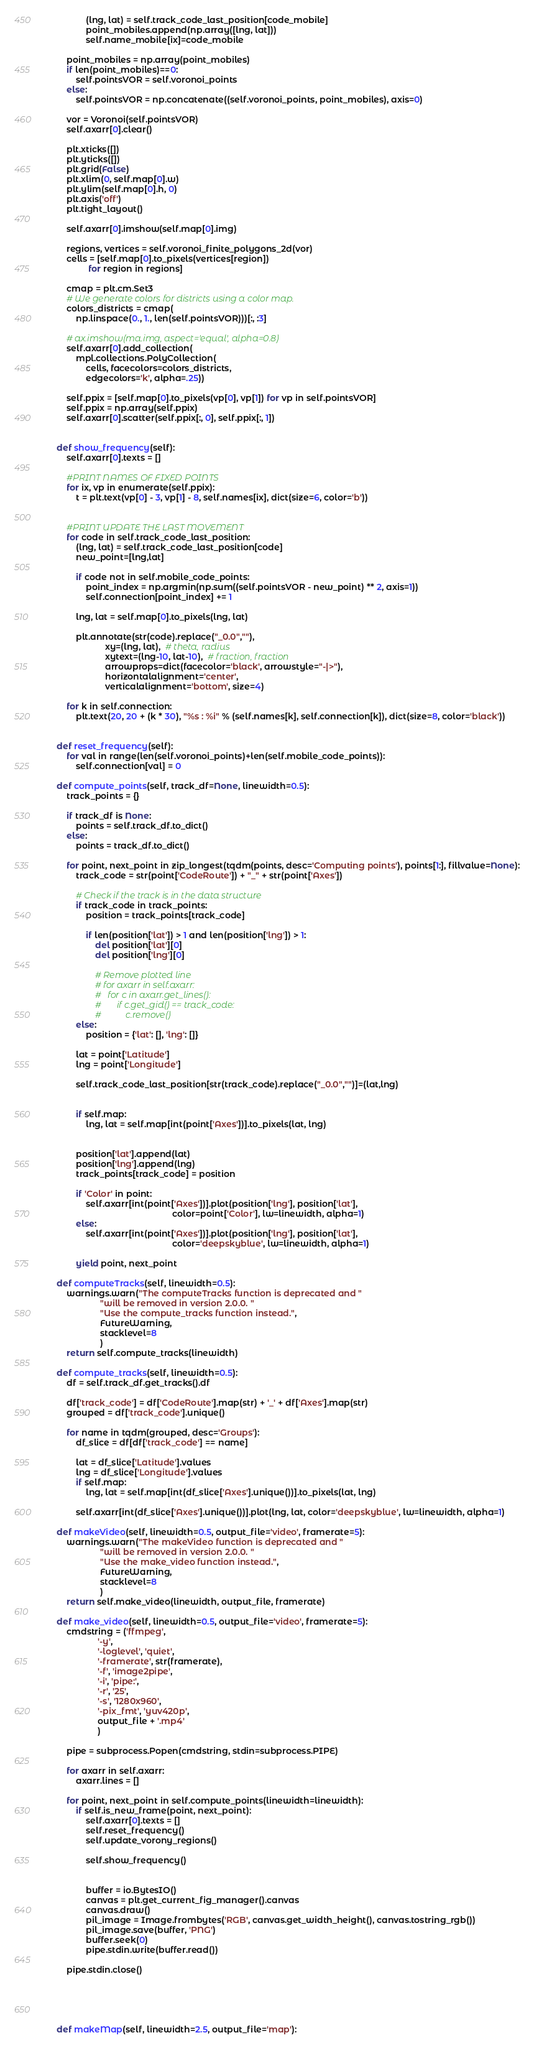Convert code to text. <code><loc_0><loc_0><loc_500><loc_500><_Python_>                (lng, lat) = self.track_code_last_position[code_mobile]
                point_mobiles.append(np.array([lng, lat]))
                self.name_mobile[ix]=code_mobile

        point_mobiles = np.array(point_mobiles)
        if len(point_mobiles)==0:
            self.pointsVOR = self.voronoi_points
        else:
            self.pointsVOR = np.concatenate((self.voronoi_points, point_mobiles), axis=0)

        vor = Voronoi(self.pointsVOR)
        self.axarr[0].clear()

        plt.xticks([])
        plt.yticks([])
        plt.grid(False)
        plt.xlim(0, self.map[0].w)
        plt.ylim(self.map[0].h, 0)
        plt.axis('off')
        plt.tight_layout()

        self.axarr[0].imshow(self.map[0].img)

        regions, vertices = self.voronoi_finite_polygons_2d(vor)
        cells = [self.map[0].to_pixels(vertices[region])
                 for region in regions]

        cmap = plt.cm.Set3
        # We generate colors for districts using a color map.
        colors_districts = cmap(
            np.linspace(0., 1., len(self.pointsVOR)))[:, :3]

        # ax.imshow(ma.img, aspect='equal', alpha=0.8)
        self.axarr[0].add_collection(
            mpl.collections.PolyCollection(
                cells, facecolors=colors_districts,
                edgecolors='k', alpha=.25))

        self.ppix = [self.map[0].to_pixels(vp[0], vp[1]) for vp in self.pointsVOR]
        self.ppix = np.array(self.ppix)
        self.axarr[0].scatter(self.ppix[:, 0], self.ppix[:, 1])


    def show_frequency(self):
        self.axarr[0].texts = []

        #PRINT NAMES OF FIXED POINTS
        for ix, vp in enumerate(self.ppix):
            t = plt.text(vp[0] - 3, vp[1] - 8, self.names[ix], dict(size=6, color='b'))


        #PRINT UPDATE THE LAST MOVEMENT
        for code in self.track_code_last_position:
            (lng, lat) = self.track_code_last_position[code]
            new_point=[lng,lat]

            if code not in self.mobile_code_points:
                point_index = np.argmin(np.sum((self.pointsVOR - new_point) ** 2, axis=1))
                self.connection[point_index] += 1

            lng, lat = self.map[0].to_pixels(lng, lat)

            plt.annotate(str(code).replace("_0.0",""),
                        xy=(lng, lat),  # theta, radius
                        xytext=(lng-10, lat-10),  # fraction, fraction
                        arrowprops=dict(facecolor='black', arrowstyle="-|>"),
                        horizontalalignment='center',
                        verticalalignment='bottom', size=4)

        for k in self.connection:
            plt.text(20, 20 + (k * 30), "%s : %i" % (self.names[k], self.connection[k]), dict(size=8, color='black'))


    def reset_frequency(self):
        for val in range(len(self.voronoi_points)+len(self.mobile_code_points)):
            self.connection[val] = 0

    def compute_points(self, track_df=None, linewidth=0.5):
        track_points = {}

        if track_df is None:
            points = self.track_df.to_dict()
        else:
            points = track_df.to_dict()

        for point, next_point in zip_longest(tqdm(points, desc='Computing points'), points[1:], fillvalue=None):
            track_code = str(point['CodeRoute']) + "_" + str(point['Axes'])

            # Check if the track is in the data structure
            if track_code in track_points:
                position = track_points[track_code]

                if len(position['lat']) > 1 and len(position['lng']) > 1:
                    del position['lat'][0]
                    del position['lng'][0]

                    # Remove plotted line
                    # for axarr in self.axarr:
                    # 	for c in axarr.get_lines():
                    # 		if c.get_gid() == track_code:
                    # 			c.remove()
            else:
                position = {'lat': [], 'lng': []}

            lat = point['Latitude']
            lng = point['Longitude']

            self.track_code_last_position[str(track_code).replace("_0.0","")]=(lat,lng)


            if self.map:
                lng, lat = self.map[int(point['Axes'])].to_pixels(lat, lng)


            position['lat'].append(lat)
            position['lng'].append(lng)
            track_points[track_code] = position

            if 'Color' in point:
                self.axarr[int(point['Axes'])].plot(position['lng'], position['lat'],
                                                    color=point['Color'], lw=linewidth, alpha=1)
            else:
                self.axarr[int(point['Axes'])].plot(position['lng'], position['lat'],
                                                    color='deepskyblue', lw=linewidth, alpha=1)

            yield point, next_point

    def computeTracks(self, linewidth=0.5):
        warnings.warn("The computeTracks function is deprecated and "
                      "will be removed in version 2.0.0. "
                      "Use the compute_tracks function instead.",
                      FutureWarning,
                      stacklevel=8
                      )
        return self.compute_tracks(linewidth)

    def compute_tracks(self, linewidth=0.5):
        df = self.track_df.get_tracks().df

        df['track_code'] = df['CodeRoute'].map(str) + '_' + df['Axes'].map(str)
        grouped = df['track_code'].unique()

        for name in tqdm(grouped, desc='Groups'):
            df_slice = df[df['track_code'] == name]

            lat = df_slice['Latitude'].values
            lng = df_slice['Longitude'].values
            if self.map:
                lng, lat = self.map[int(df_slice['Axes'].unique())].to_pixels(lat, lng)

            self.axarr[int(df_slice['Axes'].unique())].plot(lng, lat, color='deepskyblue', lw=linewidth, alpha=1)

    def makeVideo(self, linewidth=0.5, output_file='video', framerate=5):
        warnings.warn("The makeVideo function is deprecated and "
                      "will be removed in version 2.0.0. "
                      "Use the make_video function instead.",
                      FutureWarning,
                      stacklevel=8
                      )
        return self.make_video(linewidth, output_file, framerate)

    def make_video(self, linewidth=0.5, output_file='video', framerate=5):
        cmdstring = ('ffmpeg',
                     '-y',
                     '-loglevel', 'quiet',
                     '-framerate', str(framerate),
                     '-f', 'image2pipe',
                     '-i', 'pipe:',
                     '-r', '25',
                     '-s', '1280x960',
                     '-pix_fmt', 'yuv420p',
                     output_file + '.mp4'
                     )

        pipe = subprocess.Popen(cmdstring, stdin=subprocess.PIPE)

        for axarr in self.axarr:
            axarr.lines = []

        for point, next_point in self.compute_points(linewidth=linewidth):
            if self.is_new_frame(point, next_point):
                self.axarr[0].texts = []
                self.reset_frequency()
                self.update_vorony_regions()

                self.show_frequency()


                buffer = io.BytesIO()
                canvas = plt.get_current_fig_manager().canvas
                canvas.draw()
                pil_image = Image.frombytes('RGB', canvas.get_width_height(), canvas.tostring_rgb())
                pil_image.save(buffer, 'PNG')
                buffer.seek(0)
                pipe.stdin.write(buffer.read())

        pipe.stdin.close()





    def makeMap(self, linewidth=2.5, output_file='map'):</code> 